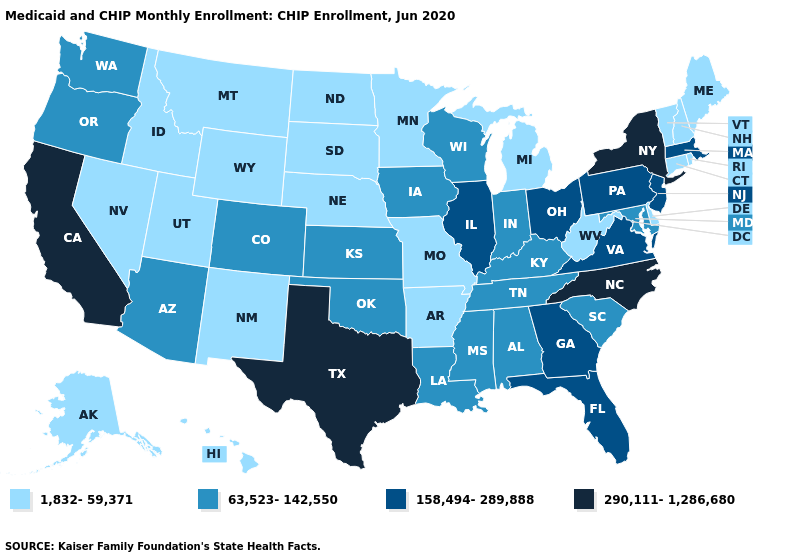Is the legend a continuous bar?
Answer briefly. No. Does Nebraska have the same value as Wyoming?
Be succinct. Yes. What is the lowest value in the USA?
Quick response, please. 1,832-59,371. Among the states that border Wyoming , does Colorado have the lowest value?
Quick response, please. No. How many symbols are there in the legend?
Quick response, please. 4. Name the states that have a value in the range 290,111-1,286,680?
Write a very short answer. California, New York, North Carolina, Texas. Is the legend a continuous bar?
Give a very brief answer. No. Does New Hampshire have the lowest value in the Northeast?
Quick response, please. Yes. What is the lowest value in the USA?
Answer briefly. 1,832-59,371. Does Wisconsin have a lower value than Florida?
Keep it brief. Yes. Name the states that have a value in the range 1,832-59,371?
Answer briefly. Alaska, Arkansas, Connecticut, Delaware, Hawaii, Idaho, Maine, Michigan, Minnesota, Missouri, Montana, Nebraska, Nevada, New Hampshire, New Mexico, North Dakota, Rhode Island, South Dakota, Utah, Vermont, West Virginia, Wyoming. What is the value of Tennessee?
Quick response, please. 63,523-142,550. What is the value of Maine?
Keep it brief. 1,832-59,371. How many symbols are there in the legend?
Answer briefly. 4. What is the highest value in states that border New Jersey?
Concise answer only. 290,111-1,286,680. 